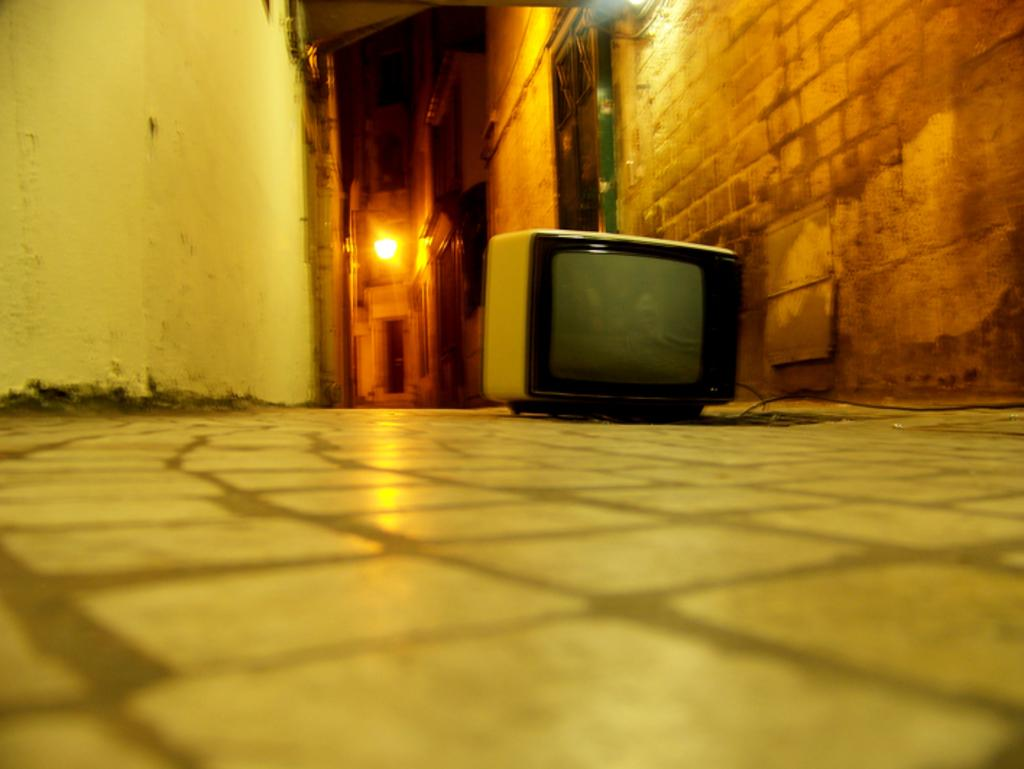What electronic device is placed on the floor in the image? There is a TV on the floor in the image. What type of structure can be seen in the image? There are walls visible in the image. Can you describe the source of light in the image? There is a light source in the image. What type of minister is present in the image? There is no minister present in the image. What color are the eyes of the person in the image? There is no person present in the image, so it is not possible to determine the color of their eyes. 